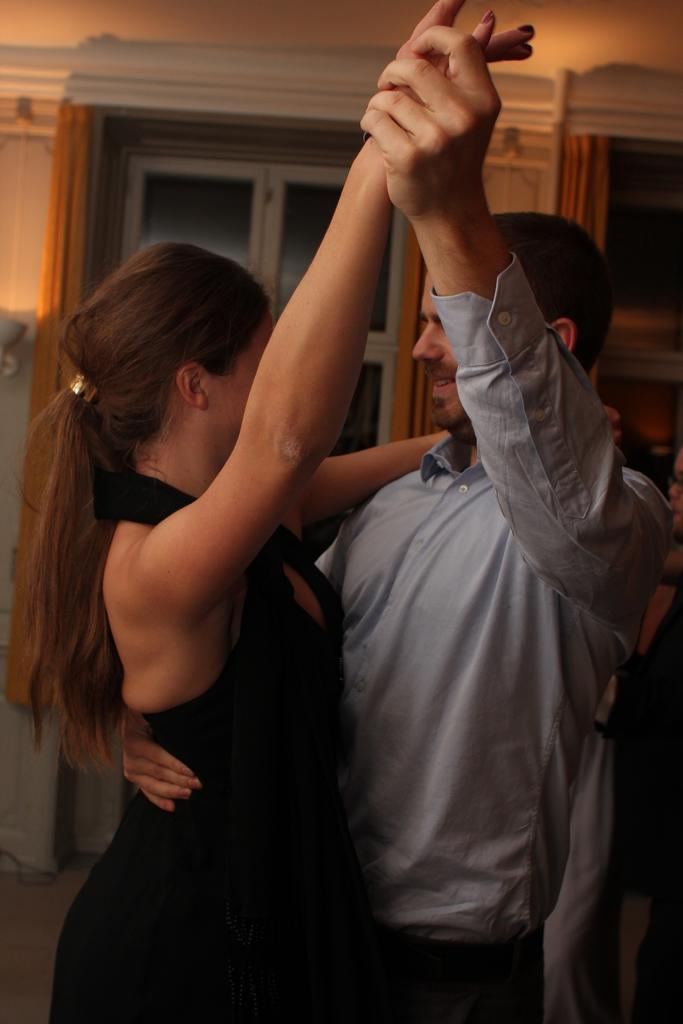What are the two people in the image doing? The man and woman in the image are dancing. Can you describe the gender of the two people in the image? There is a man and a woman in the image. What can be seen in the background of the image? There is a door in the background of the image. What is the division between the man and woman in the image? There is no division between the man and woman in the image; they are dancing together. What is the limit of the dance floor in the image? There is no specific limit of the dance floor visible in the image, as the focus is on the man and woman dancing. 